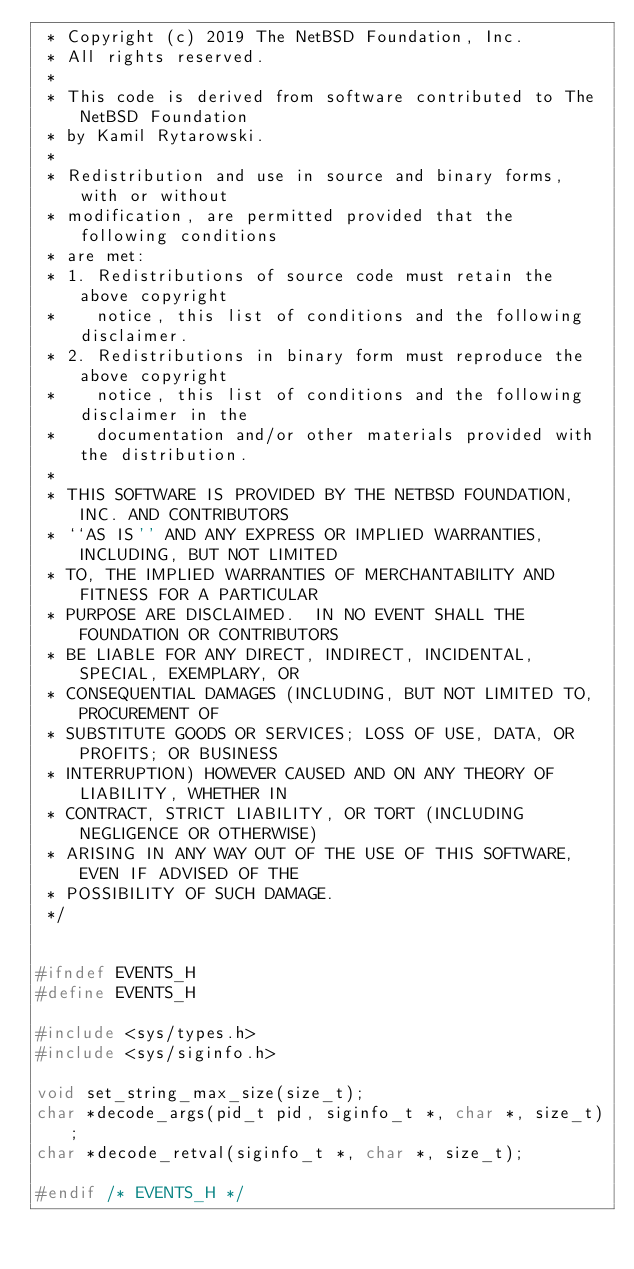<code> <loc_0><loc_0><loc_500><loc_500><_C_> * Copyright (c) 2019 The NetBSD Foundation, Inc.
 * All rights reserved.
 *
 * This code is derived from software contributed to The NetBSD Foundation
 * by Kamil Rytarowski.
 *
 * Redistribution and use in source and binary forms, with or without
 * modification, are permitted provided that the following conditions
 * are met:
 * 1. Redistributions of source code must retain the above copyright
 *    notice, this list of conditions and the following disclaimer.
 * 2. Redistributions in binary form must reproduce the above copyright
 *    notice, this list of conditions and the following disclaimer in the
 *    documentation and/or other materials provided with the distribution.
 *
 * THIS SOFTWARE IS PROVIDED BY THE NETBSD FOUNDATION, INC. AND CONTRIBUTORS
 * ``AS IS'' AND ANY EXPRESS OR IMPLIED WARRANTIES, INCLUDING, BUT NOT LIMITED
 * TO, THE IMPLIED WARRANTIES OF MERCHANTABILITY AND FITNESS FOR A PARTICULAR
 * PURPOSE ARE DISCLAIMED.  IN NO EVENT SHALL THE FOUNDATION OR CONTRIBUTORS
 * BE LIABLE FOR ANY DIRECT, INDIRECT, INCIDENTAL, SPECIAL, EXEMPLARY, OR
 * CONSEQUENTIAL DAMAGES (INCLUDING, BUT NOT LIMITED TO, PROCUREMENT OF
 * SUBSTITUTE GOODS OR SERVICES; LOSS OF USE, DATA, OR PROFITS; OR BUSINESS
 * INTERRUPTION) HOWEVER CAUSED AND ON ANY THEORY OF LIABILITY, WHETHER IN
 * CONTRACT, STRICT LIABILITY, OR TORT (INCLUDING NEGLIGENCE OR OTHERWISE)
 * ARISING IN ANY WAY OUT OF THE USE OF THIS SOFTWARE, EVEN IF ADVISED OF THE
 * POSSIBILITY OF SUCH DAMAGE.
 */


#ifndef EVENTS_H
#define EVENTS_H

#include <sys/types.h>
#include <sys/siginfo.h>

void set_string_max_size(size_t);
char *decode_args(pid_t pid, siginfo_t *, char *, size_t);
char *decode_retval(siginfo_t *, char *, size_t);

#endif /* EVENTS_H */
</code> 